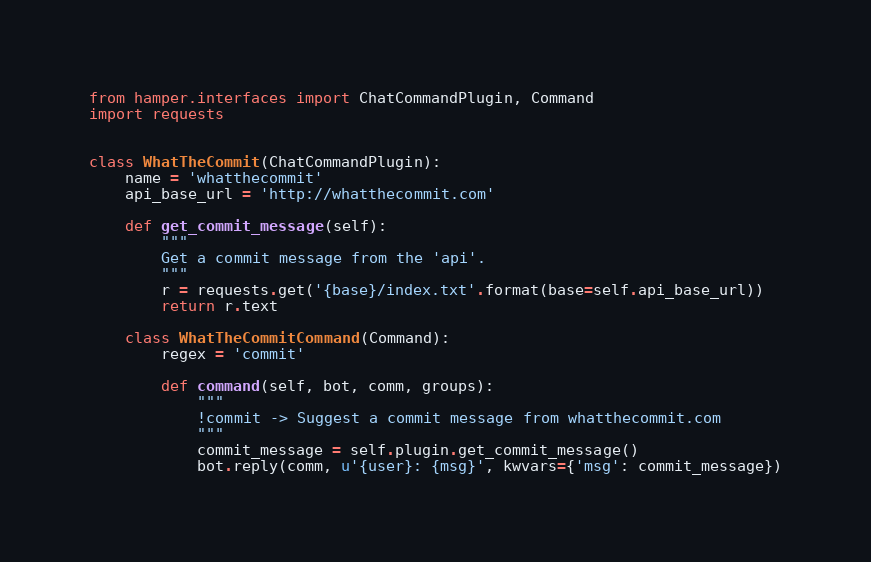<code> <loc_0><loc_0><loc_500><loc_500><_Python_>from hamper.interfaces import ChatCommandPlugin, Command
import requests


class WhatTheCommit(ChatCommandPlugin):
    name = 'whatthecommit'
    api_base_url = 'http://whatthecommit.com'

    def get_commit_message(self):
        """
        Get a commit message from the 'api'.
        """
        r = requests.get('{base}/index.txt'.format(base=self.api_base_url))
        return r.text

    class WhatTheCommitCommand(Command):
        regex = 'commit'

        def command(self, bot, comm, groups):
            """
            !commit -> Suggest a commit message from whatthecommit.com
            """
            commit_message = self.plugin.get_commit_message()
            bot.reply(comm, u'{user}: {msg}', kwvars={'msg': commit_message})
</code> 